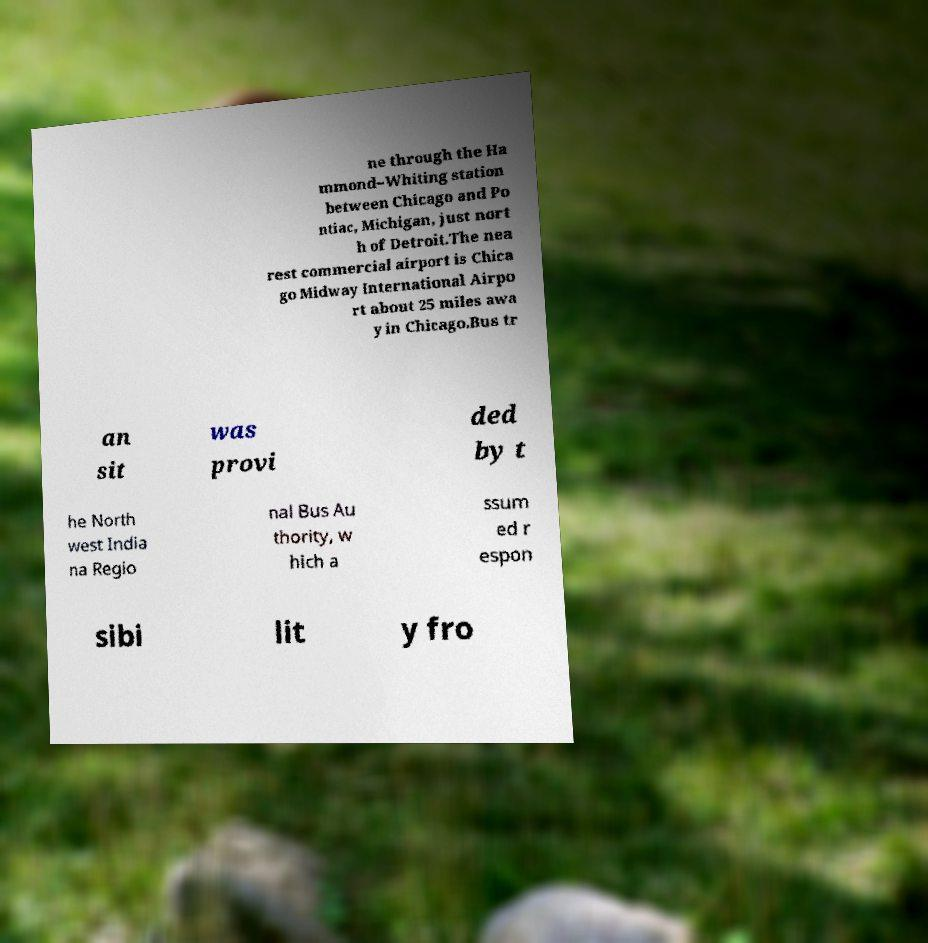For documentation purposes, I need the text within this image transcribed. Could you provide that? ne through the Ha mmond–Whiting station between Chicago and Po ntiac, Michigan, just nort h of Detroit.The nea rest commercial airport is Chica go Midway International Airpo rt about 25 miles awa y in Chicago.Bus tr an sit was provi ded by t he North west India na Regio nal Bus Au thority, w hich a ssum ed r espon sibi lit y fro 